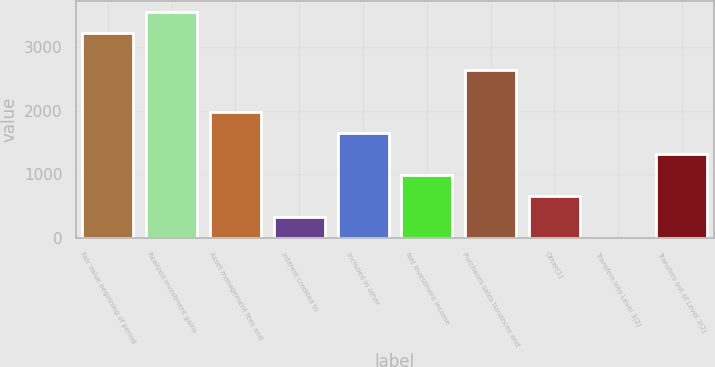Convert chart. <chart><loc_0><loc_0><loc_500><loc_500><bar_chart><fcel>Fair Value beginning of period<fcel>Realized investment gains<fcel>Asset management fees and<fcel>Interest credited to<fcel>Included in other<fcel>Net investment income<fcel>Purchases sales issuances and<fcel>Other(1)<fcel>Transfers into Level 3(2)<fcel>Transfers out of Level 3(2)<nl><fcel>3229<fcel>3560.23<fcel>1988.04<fcel>331.89<fcel>1656.81<fcel>994.35<fcel>2650.5<fcel>663.12<fcel>0.66<fcel>1325.58<nl></chart> 